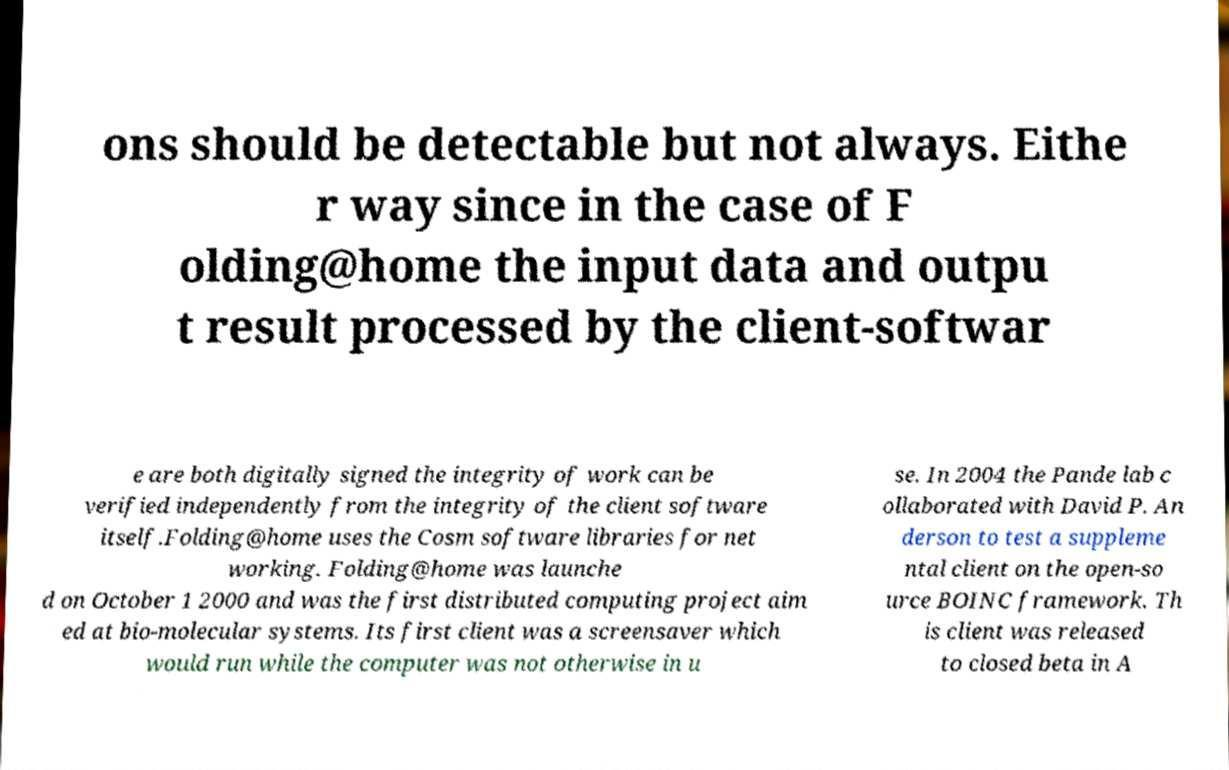Could you assist in decoding the text presented in this image and type it out clearly? ons should be detectable but not always. Eithe r way since in the case of F olding@home the input data and outpu t result processed by the client-softwar e are both digitally signed the integrity of work can be verified independently from the integrity of the client software itself.Folding@home uses the Cosm software libraries for net working. Folding@home was launche d on October 1 2000 and was the first distributed computing project aim ed at bio-molecular systems. Its first client was a screensaver which would run while the computer was not otherwise in u se. In 2004 the Pande lab c ollaborated with David P. An derson to test a suppleme ntal client on the open-so urce BOINC framework. Th is client was released to closed beta in A 